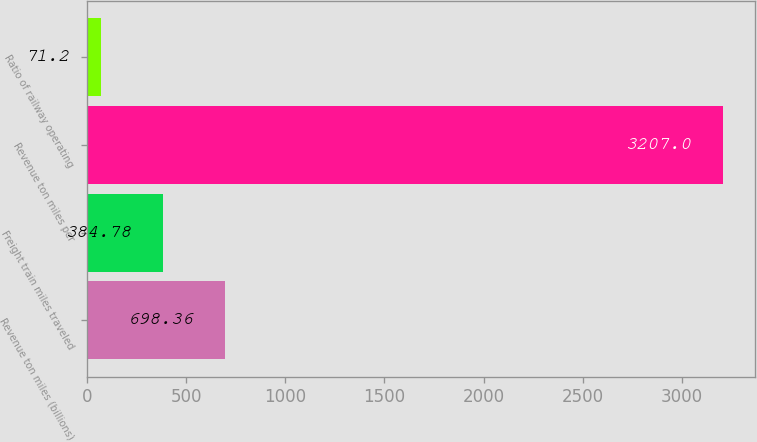<chart> <loc_0><loc_0><loc_500><loc_500><bar_chart><fcel>Revenue ton miles (billions)<fcel>Freight train miles traveled<fcel>Revenue ton miles per<fcel>Ratio of railway operating<nl><fcel>698.36<fcel>384.78<fcel>3207<fcel>71.2<nl></chart> 